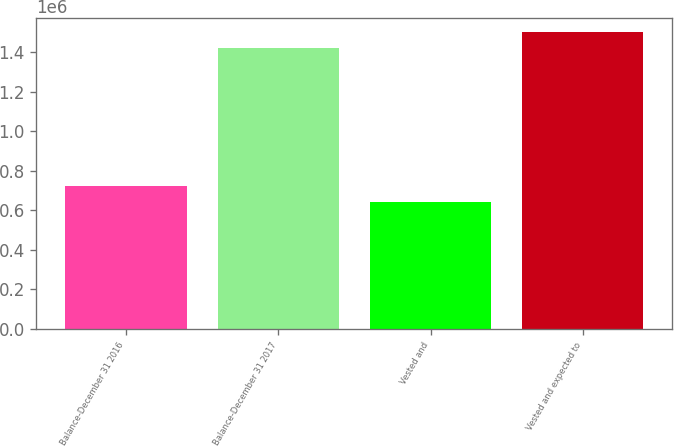<chart> <loc_0><loc_0><loc_500><loc_500><bar_chart><fcel>Balance-December 31 2016<fcel>Balance-December 31 2017<fcel>Vested and<fcel>Vested and expected to<nl><fcel>720974<fcel>1.42264e+06<fcel>643012<fcel>1.5006e+06<nl></chart> 